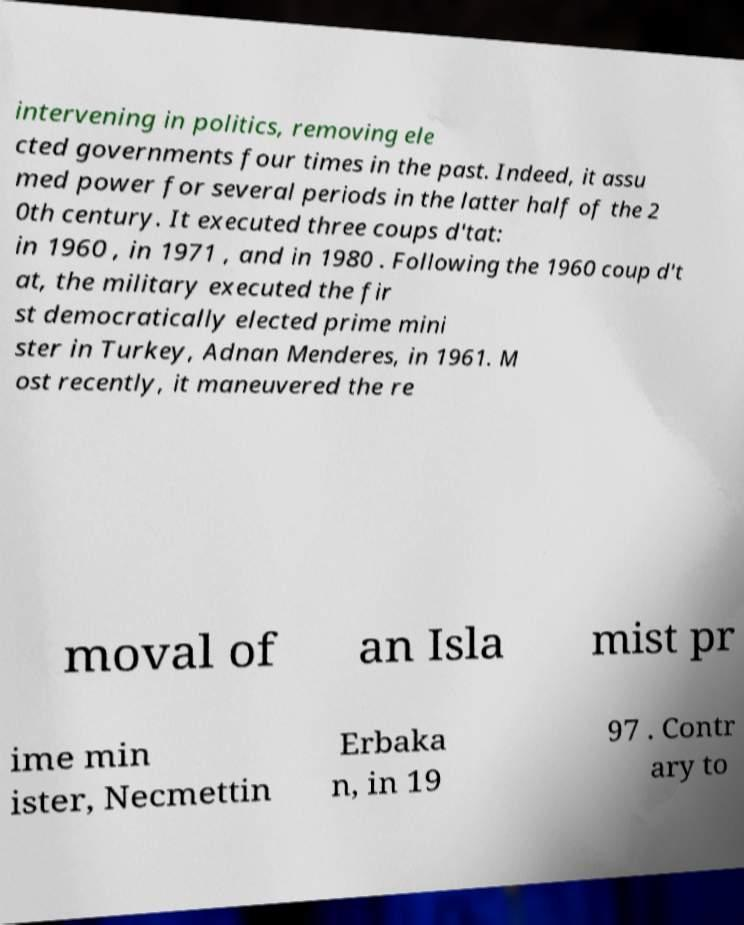For documentation purposes, I need the text within this image transcribed. Could you provide that? intervening in politics, removing ele cted governments four times in the past. Indeed, it assu med power for several periods in the latter half of the 2 0th century. It executed three coups d'tat: in 1960 , in 1971 , and in 1980 . Following the 1960 coup d't at, the military executed the fir st democratically elected prime mini ster in Turkey, Adnan Menderes, in 1961. M ost recently, it maneuvered the re moval of an Isla mist pr ime min ister, Necmettin Erbaka n, in 19 97 . Contr ary to 